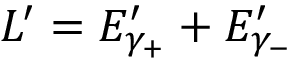<formula> <loc_0><loc_0><loc_500><loc_500>L ^ { \prime } = E _ { \gamma _ { + } } ^ { \prime } + E _ { \gamma _ { - } } ^ { \prime }</formula> 